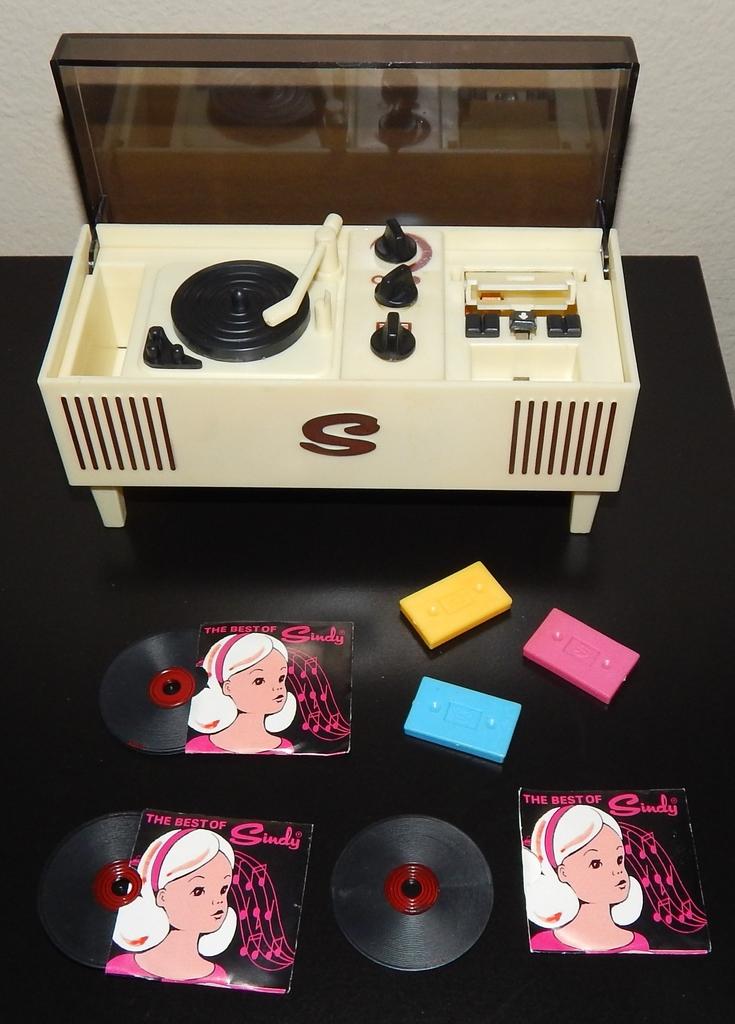What letter is on the front?
Your answer should be very brief. S. 